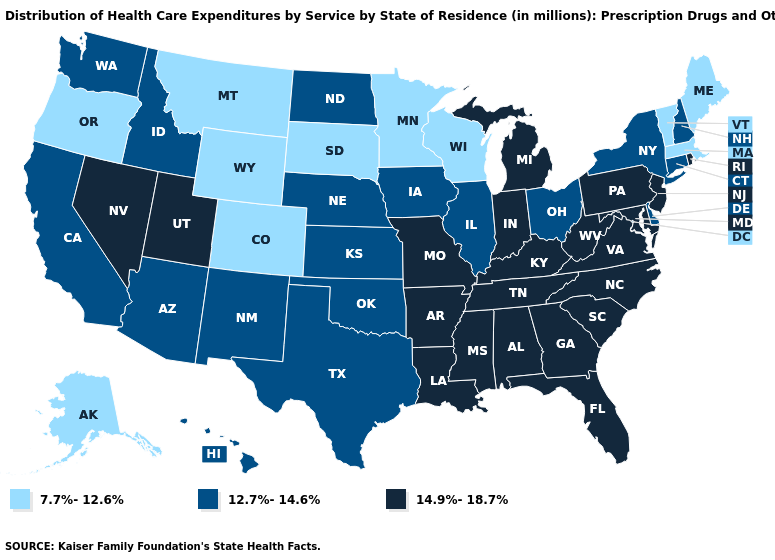Name the states that have a value in the range 14.9%-18.7%?
Give a very brief answer. Alabama, Arkansas, Florida, Georgia, Indiana, Kentucky, Louisiana, Maryland, Michigan, Mississippi, Missouri, Nevada, New Jersey, North Carolina, Pennsylvania, Rhode Island, South Carolina, Tennessee, Utah, Virginia, West Virginia. What is the value of Washington?
Short answer required. 12.7%-14.6%. Name the states that have a value in the range 7.7%-12.6%?
Concise answer only. Alaska, Colorado, Maine, Massachusetts, Minnesota, Montana, Oregon, South Dakota, Vermont, Wisconsin, Wyoming. What is the value of Massachusetts?
Concise answer only. 7.7%-12.6%. Name the states that have a value in the range 12.7%-14.6%?
Keep it brief. Arizona, California, Connecticut, Delaware, Hawaii, Idaho, Illinois, Iowa, Kansas, Nebraska, New Hampshire, New Mexico, New York, North Dakota, Ohio, Oklahoma, Texas, Washington. What is the lowest value in states that border South Carolina?
Give a very brief answer. 14.9%-18.7%. Does Pennsylvania have a higher value than Louisiana?
Keep it brief. No. What is the value of Virginia?
Be succinct. 14.9%-18.7%. Name the states that have a value in the range 14.9%-18.7%?
Answer briefly. Alabama, Arkansas, Florida, Georgia, Indiana, Kentucky, Louisiana, Maryland, Michigan, Mississippi, Missouri, Nevada, New Jersey, North Carolina, Pennsylvania, Rhode Island, South Carolina, Tennessee, Utah, Virginia, West Virginia. What is the lowest value in states that border Maryland?
Concise answer only. 12.7%-14.6%. Name the states that have a value in the range 14.9%-18.7%?
Keep it brief. Alabama, Arkansas, Florida, Georgia, Indiana, Kentucky, Louisiana, Maryland, Michigan, Mississippi, Missouri, Nevada, New Jersey, North Carolina, Pennsylvania, Rhode Island, South Carolina, Tennessee, Utah, Virginia, West Virginia. What is the highest value in the USA?
Concise answer only. 14.9%-18.7%. Name the states that have a value in the range 14.9%-18.7%?
Concise answer only. Alabama, Arkansas, Florida, Georgia, Indiana, Kentucky, Louisiana, Maryland, Michigan, Mississippi, Missouri, Nevada, New Jersey, North Carolina, Pennsylvania, Rhode Island, South Carolina, Tennessee, Utah, Virginia, West Virginia. Does the first symbol in the legend represent the smallest category?
Keep it brief. Yes. 